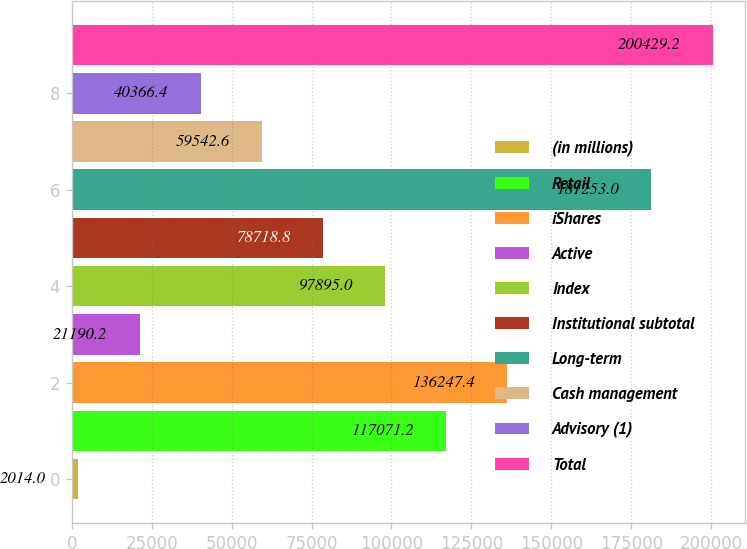Convert chart. <chart><loc_0><loc_0><loc_500><loc_500><bar_chart><fcel>(in millions)<fcel>Retail<fcel>iShares<fcel>Active<fcel>Index<fcel>Institutional subtotal<fcel>Long-term<fcel>Cash management<fcel>Advisory (1)<fcel>Total<nl><fcel>2014<fcel>117071<fcel>136247<fcel>21190.2<fcel>97895<fcel>78718.8<fcel>181253<fcel>59542.6<fcel>40366.4<fcel>200429<nl></chart> 